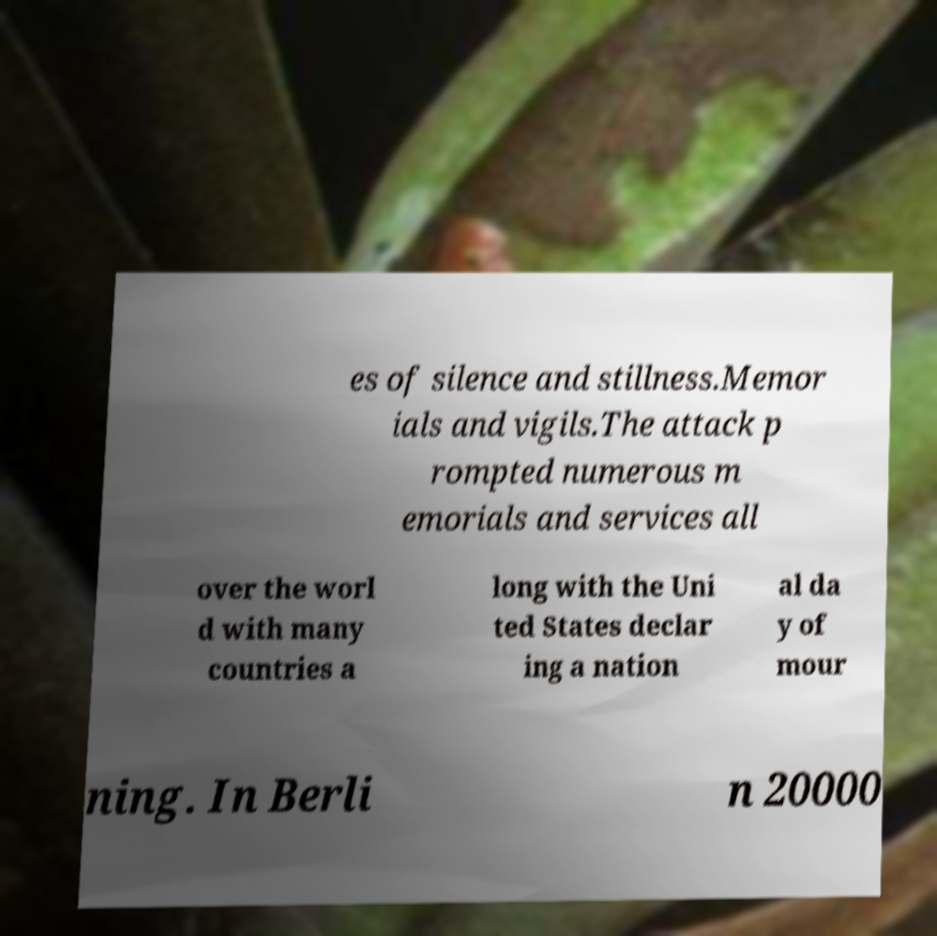Can you read and provide the text displayed in the image?This photo seems to have some interesting text. Can you extract and type it out for me? es of silence and stillness.Memor ials and vigils.The attack p rompted numerous m emorials and services all over the worl d with many countries a long with the Uni ted States declar ing a nation al da y of mour ning. In Berli n 20000 